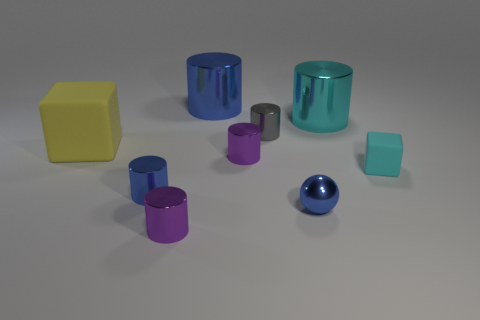Is the shape of the tiny cyan thing the same as the yellow rubber object?
Offer a very short reply. Yes. Is the number of yellow objects that are to the right of the cyan matte block less than the number of tiny purple objects behind the blue sphere?
Provide a succinct answer. Yes. What number of tiny metallic cylinders are in front of the cyan cylinder?
Provide a short and direct response. 4. Does the tiny object that is on the right side of the large cyan cylinder have the same shape as the big yellow rubber thing to the left of the large blue shiny cylinder?
Your answer should be very brief. Yes. How many other things are the same color as the large rubber block?
Offer a very short reply. 0. What material is the blue object that is on the left side of the blue shiny cylinder right of the tiny metal cylinder in front of the tiny sphere?
Your response must be concise. Metal. The cube that is on the left side of the small purple metal object behind the blue metal ball is made of what material?
Keep it short and to the point. Rubber. Are there fewer large cyan cylinders that are left of the cyan matte object than purple cylinders?
Provide a succinct answer. Yes. There is a rubber object in front of the big yellow rubber cube; what shape is it?
Your answer should be very brief. Cube. Does the gray object have the same size as the purple cylinder that is behind the blue shiny sphere?
Provide a succinct answer. Yes. 